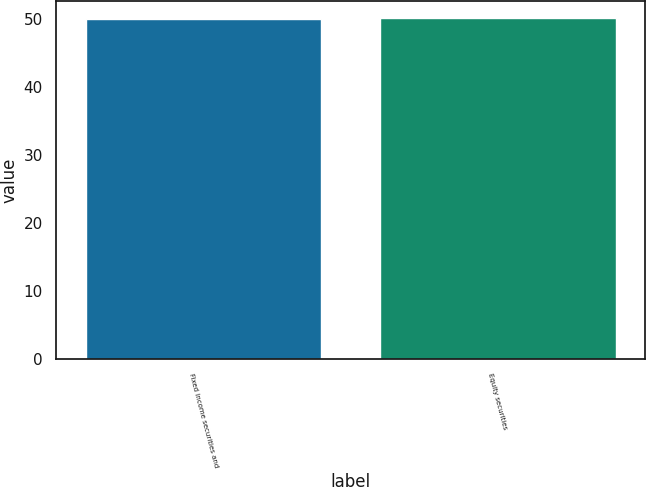Convert chart to OTSL. <chart><loc_0><loc_0><loc_500><loc_500><bar_chart><fcel>Fixed income securities and<fcel>Equity securities<nl><fcel>50<fcel>50.1<nl></chart> 